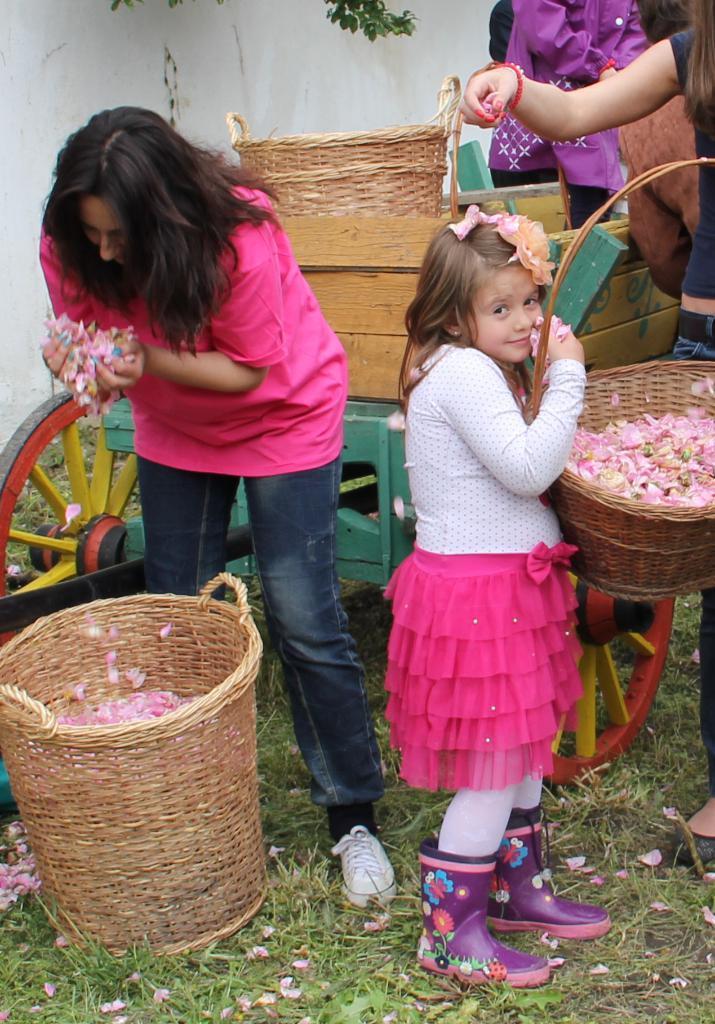In one or two sentences, can you explain what this image depicts? In this image I can see a woman is there, she wore pink color top. Behind her there is the cart, a cute girl is looking at this side by holding the basket in her hands. 